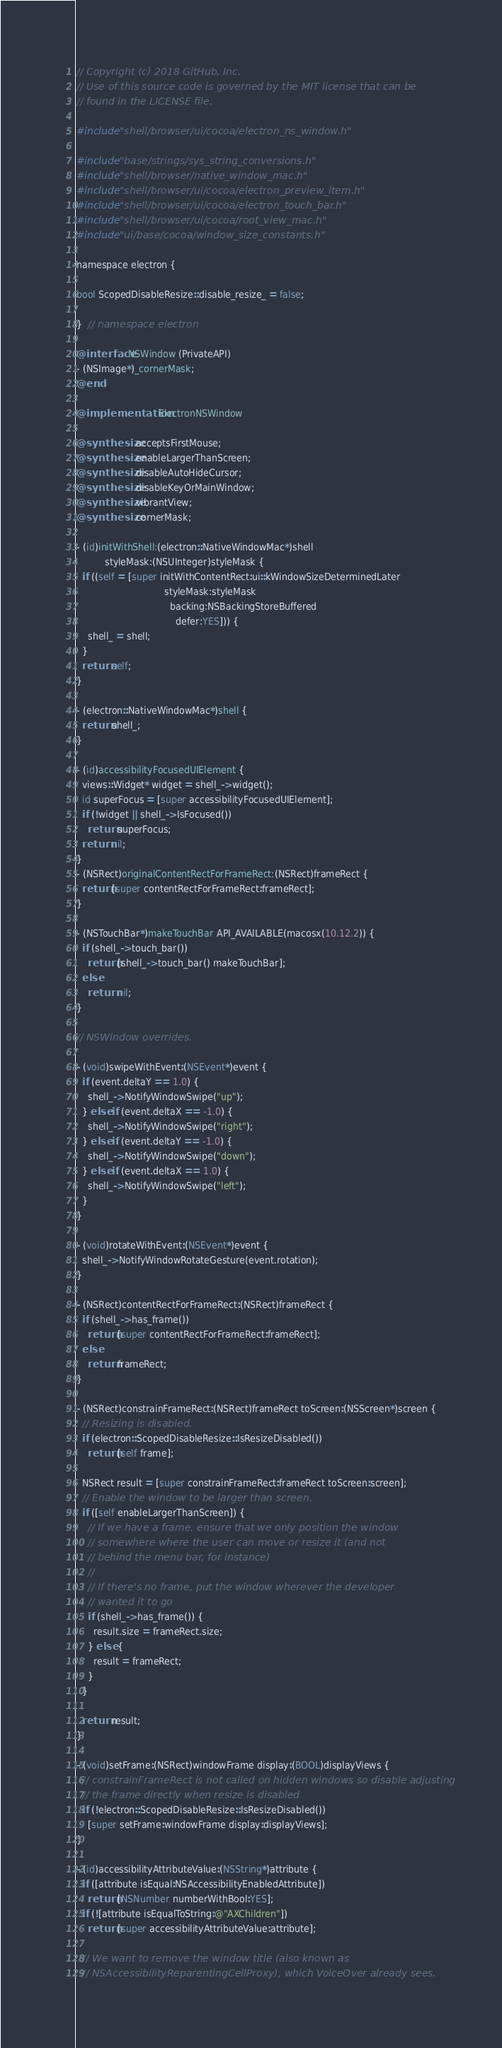Convert code to text. <code><loc_0><loc_0><loc_500><loc_500><_ObjectiveC_>// Copyright (c) 2018 GitHub, Inc.
// Use of this source code is governed by the MIT license that can be
// found in the LICENSE file.

#include "shell/browser/ui/cocoa/electron_ns_window.h"

#include "base/strings/sys_string_conversions.h"
#include "shell/browser/native_window_mac.h"
#include "shell/browser/ui/cocoa/electron_preview_item.h"
#include "shell/browser/ui/cocoa/electron_touch_bar.h"
#include "shell/browser/ui/cocoa/root_view_mac.h"
#include "ui/base/cocoa/window_size_constants.h"

namespace electron {

bool ScopedDisableResize::disable_resize_ = false;

}  // namespace electron

@interface NSWindow (PrivateAPI)
- (NSImage*)_cornerMask;
@end

@implementation ElectronNSWindow

@synthesize acceptsFirstMouse;
@synthesize enableLargerThanScreen;
@synthesize disableAutoHideCursor;
@synthesize disableKeyOrMainWindow;
@synthesize vibrantView;
@synthesize cornerMask;

- (id)initWithShell:(electron::NativeWindowMac*)shell
          styleMask:(NSUInteger)styleMask {
  if ((self = [super initWithContentRect:ui::kWindowSizeDeterminedLater
                               styleMask:styleMask
                                 backing:NSBackingStoreBuffered
                                   defer:YES])) {
    shell_ = shell;
  }
  return self;
}

- (electron::NativeWindowMac*)shell {
  return shell_;
}

- (id)accessibilityFocusedUIElement {
  views::Widget* widget = shell_->widget();
  id superFocus = [super accessibilityFocusedUIElement];
  if (!widget || shell_->IsFocused())
    return superFocus;
  return nil;
}
- (NSRect)originalContentRectForFrameRect:(NSRect)frameRect {
  return [super contentRectForFrameRect:frameRect];
}

- (NSTouchBar*)makeTouchBar API_AVAILABLE(macosx(10.12.2)) {
  if (shell_->touch_bar())
    return [shell_->touch_bar() makeTouchBar];
  else
    return nil;
}

// NSWindow overrides.

- (void)swipeWithEvent:(NSEvent*)event {
  if (event.deltaY == 1.0) {
    shell_->NotifyWindowSwipe("up");
  } else if (event.deltaX == -1.0) {
    shell_->NotifyWindowSwipe("right");
  } else if (event.deltaY == -1.0) {
    shell_->NotifyWindowSwipe("down");
  } else if (event.deltaX == 1.0) {
    shell_->NotifyWindowSwipe("left");
  }
}

- (void)rotateWithEvent:(NSEvent*)event {
  shell_->NotifyWindowRotateGesture(event.rotation);
}

- (NSRect)contentRectForFrameRect:(NSRect)frameRect {
  if (shell_->has_frame())
    return [super contentRectForFrameRect:frameRect];
  else
    return frameRect;
}

- (NSRect)constrainFrameRect:(NSRect)frameRect toScreen:(NSScreen*)screen {
  // Resizing is disabled.
  if (electron::ScopedDisableResize::IsResizeDisabled())
    return [self frame];

  NSRect result = [super constrainFrameRect:frameRect toScreen:screen];
  // Enable the window to be larger than screen.
  if ([self enableLargerThanScreen]) {
    // If we have a frame, ensure that we only position the window
    // somewhere where the user can move or resize it (and not
    // behind the menu bar, for instance)
    //
    // If there's no frame, put the window wherever the developer
    // wanted it to go
    if (shell_->has_frame()) {
      result.size = frameRect.size;
    } else {
      result = frameRect;
    }
  }

  return result;
}

- (void)setFrame:(NSRect)windowFrame display:(BOOL)displayViews {
  // constrainFrameRect is not called on hidden windows so disable adjusting
  // the frame directly when resize is disabled
  if (!electron::ScopedDisableResize::IsResizeDisabled())
    [super setFrame:windowFrame display:displayViews];
}

- (id)accessibilityAttributeValue:(NSString*)attribute {
  if ([attribute isEqual:NSAccessibilityEnabledAttribute])
    return [NSNumber numberWithBool:YES];
  if (![attribute isEqualToString:@"AXChildren"])
    return [super accessibilityAttributeValue:attribute];

  // We want to remove the window title (also known as
  // NSAccessibilityReparentingCellProxy), which VoiceOver already sees.</code> 